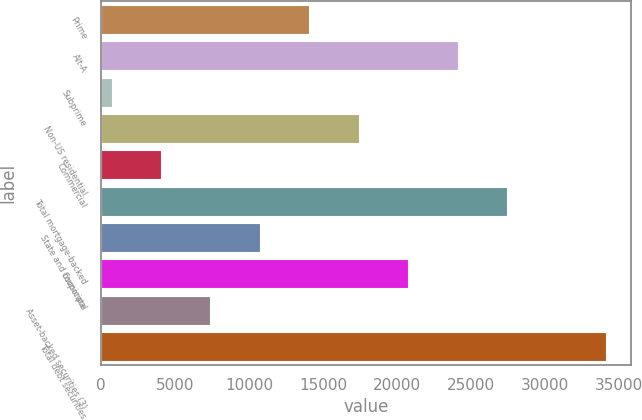<chart> <loc_0><loc_0><loc_500><loc_500><bar_chart><fcel>Prime<fcel>Alt-A<fcel>Subprime<fcel>Non-US residential<fcel>Commercial<fcel>Total mortgage-backed<fcel>State and municipal<fcel>Corporate<fcel>Asset-backed securities (3)<fcel>Total debt securities<nl><fcel>14079.6<fcel>24108.3<fcel>708<fcel>17422.5<fcel>4050.9<fcel>27451.2<fcel>10736.7<fcel>20765.4<fcel>7393.8<fcel>34137<nl></chart> 